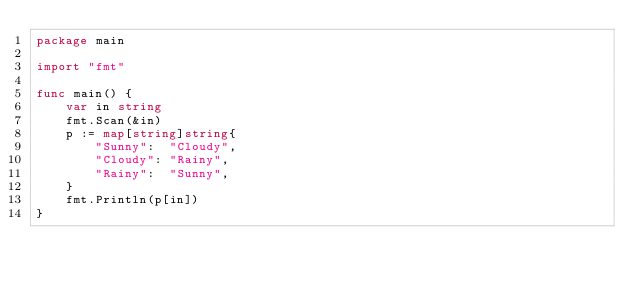<code> <loc_0><loc_0><loc_500><loc_500><_Go_>package main

import "fmt"

func main() {
	var in string
	fmt.Scan(&in)
	p := map[string]string{
		"Sunny":  "Cloudy",
		"Cloudy": "Rainy",
		"Rainy":  "Sunny",
	}
	fmt.Println(p[in])
}
</code> 